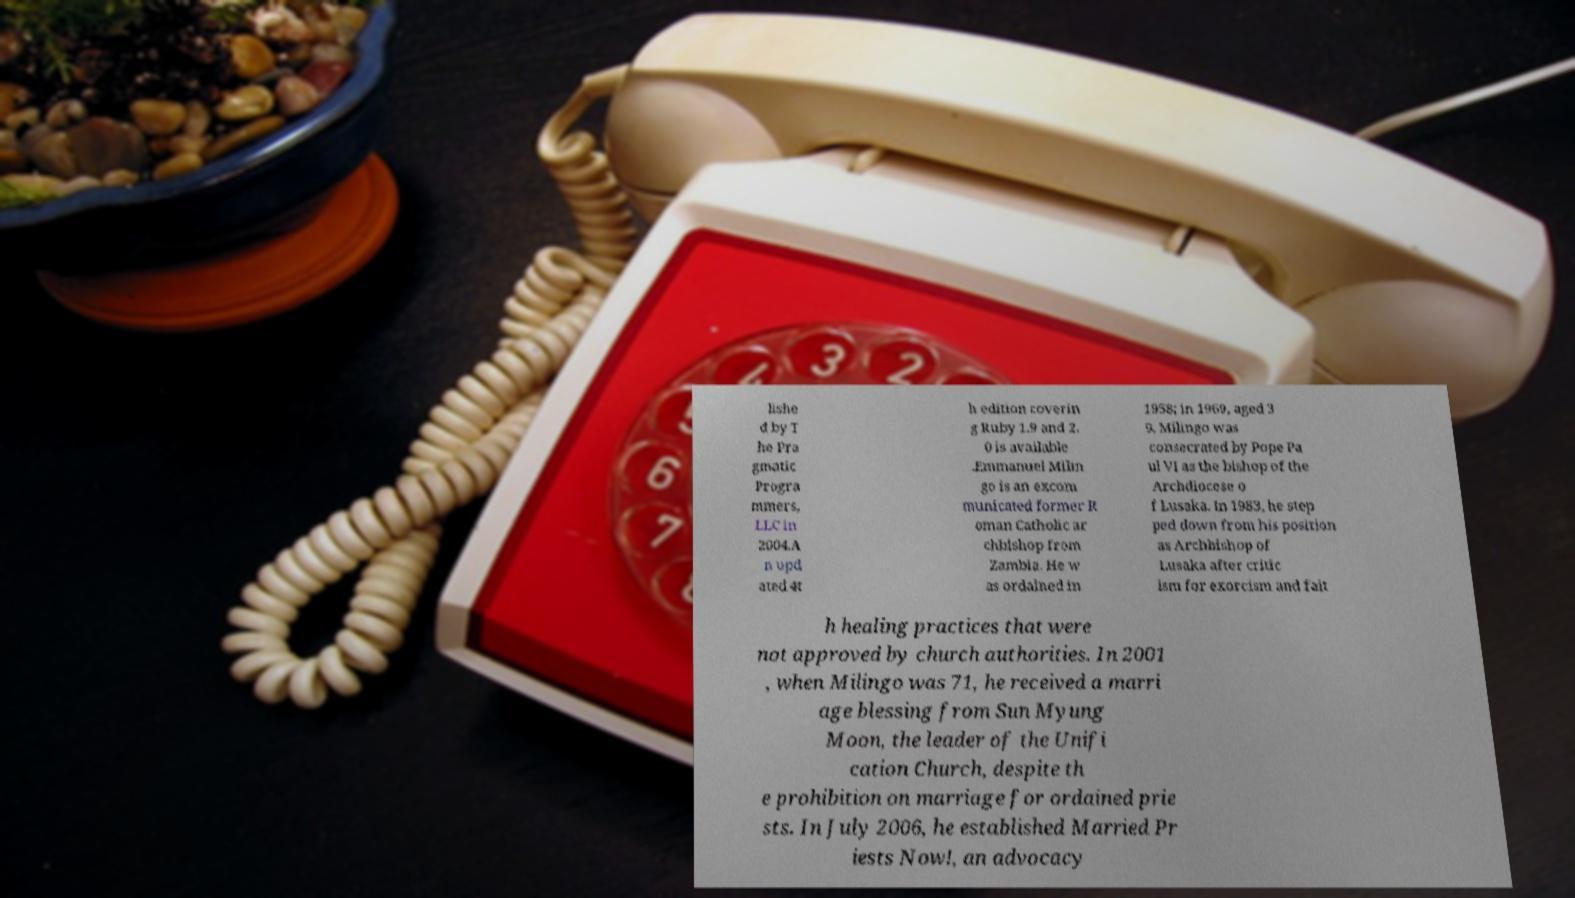Could you assist in decoding the text presented in this image and type it out clearly? lishe d by T he Pra gmatic Progra mmers, LLC in 2004.A n upd ated 4t h edition coverin g Ruby 1.9 and 2. 0 is available .Emmanuel Milin go is an excom municated former R oman Catholic ar chbishop from Zambia. He w as ordained in 1958; in 1969, aged 3 9, Milingo was consecrated by Pope Pa ul VI as the bishop of the Archdiocese o f Lusaka. In 1983, he step ped down from his position as Archbishop of Lusaka after critic ism for exorcism and fait h healing practices that were not approved by church authorities. In 2001 , when Milingo was 71, he received a marri age blessing from Sun Myung Moon, the leader of the Unifi cation Church, despite th e prohibition on marriage for ordained prie sts. In July 2006, he established Married Pr iests Now!, an advocacy 